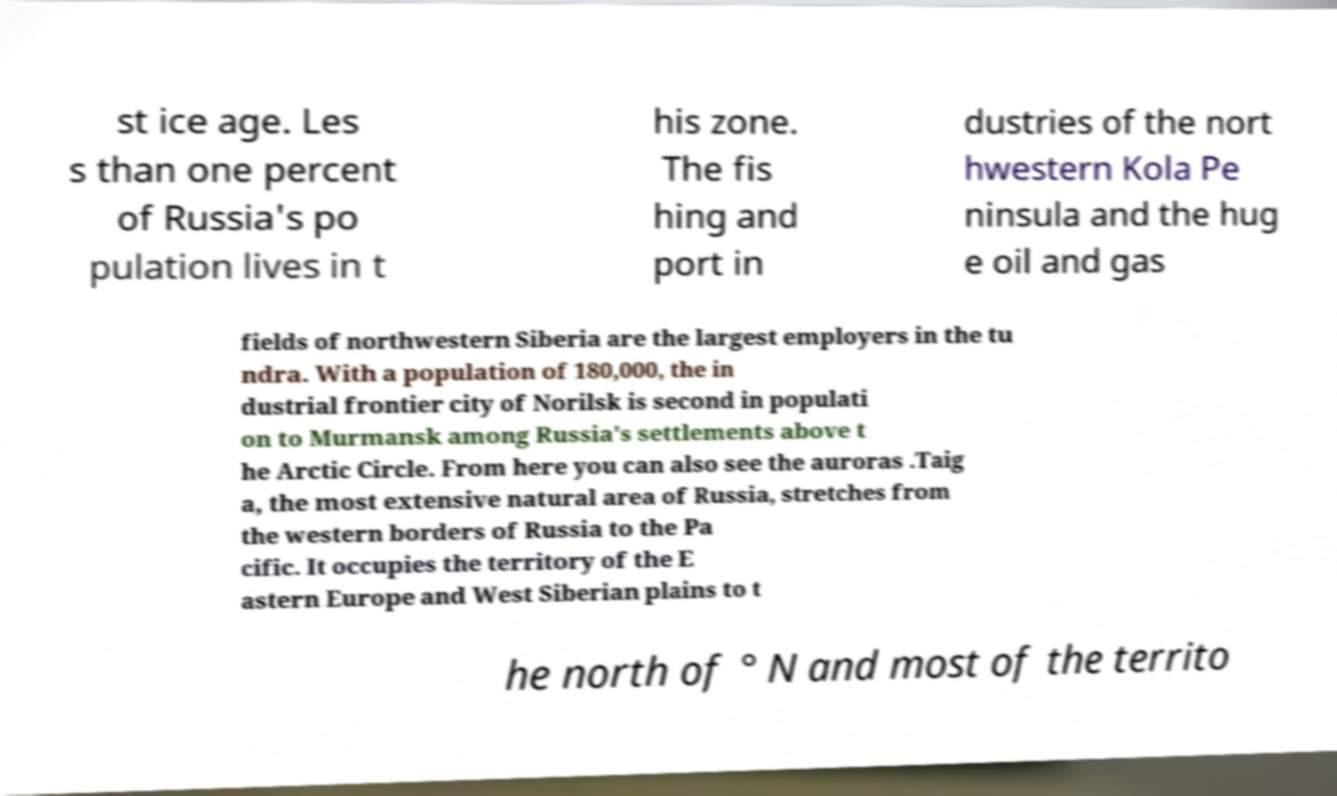Can you accurately transcribe the text from the provided image for me? st ice age. Les s than one percent of Russia's po pulation lives in t his zone. The fis hing and port in dustries of the nort hwestern Kola Pe ninsula and the hug e oil and gas fields of northwestern Siberia are the largest employers in the tu ndra. With a population of 180,000, the in dustrial frontier city of Norilsk is second in populati on to Murmansk among Russia's settlements above t he Arctic Circle. From here you can also see the auroras .Taig a, the most extensive natural area of Russia, stretches from the western borders of Russia to the Pa cific. It occupies the territory of the E astern Europe and West Siberian plains to t he north of ° N and most of the territo 